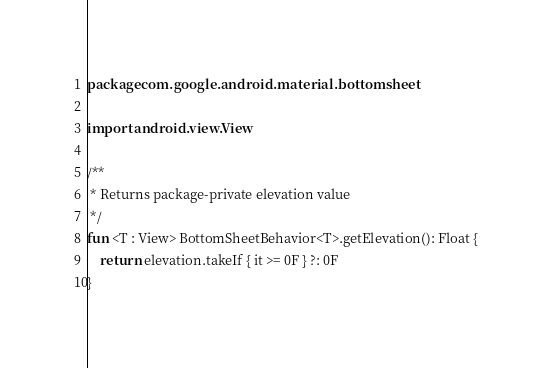Convert code to text. <code><loc_0><loc_0><loc_500><loc_500><_Kotlin_>package com.google.android.material.bottomsheet

import android.view.View

/**
 * Returns package-private elevation value
 */
fun <T : View> BottomSheetBehavior<T>.getElevation(): Float {
    return elevation.takeIf { it >= 0F } ?: 0F
}
</code> 